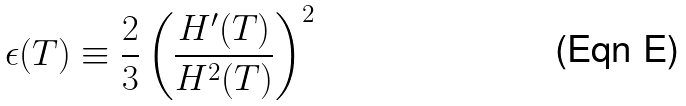Convert formula to latex. <formula><loc_0><loc_0><loc_500><loc_500>\epsilon ( T ) \equiv \frac { 2 } { 3 } \left ( \frac { H ^ { \prime } ( T ) } { H ^ { 2 } ( T ) } \right ) ^ { 2 }</formula> 